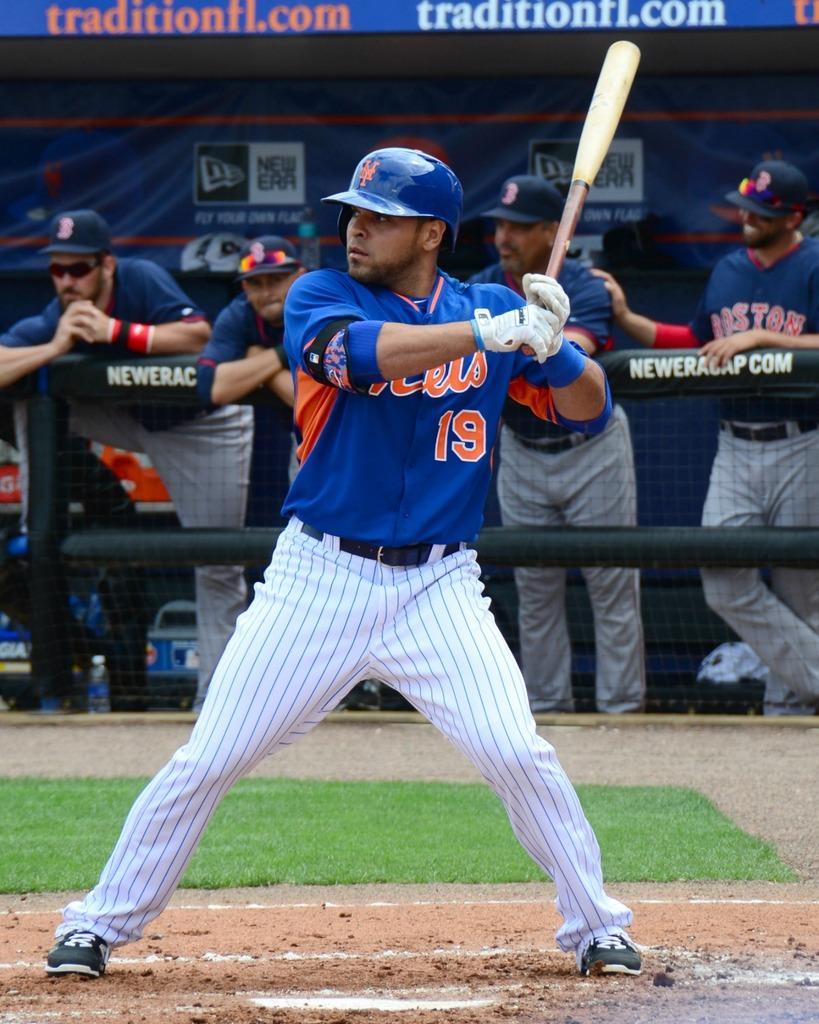<image>
Create a compact narrative representing the image presented. Batter number 19 is ready for the ball to be pitched. 